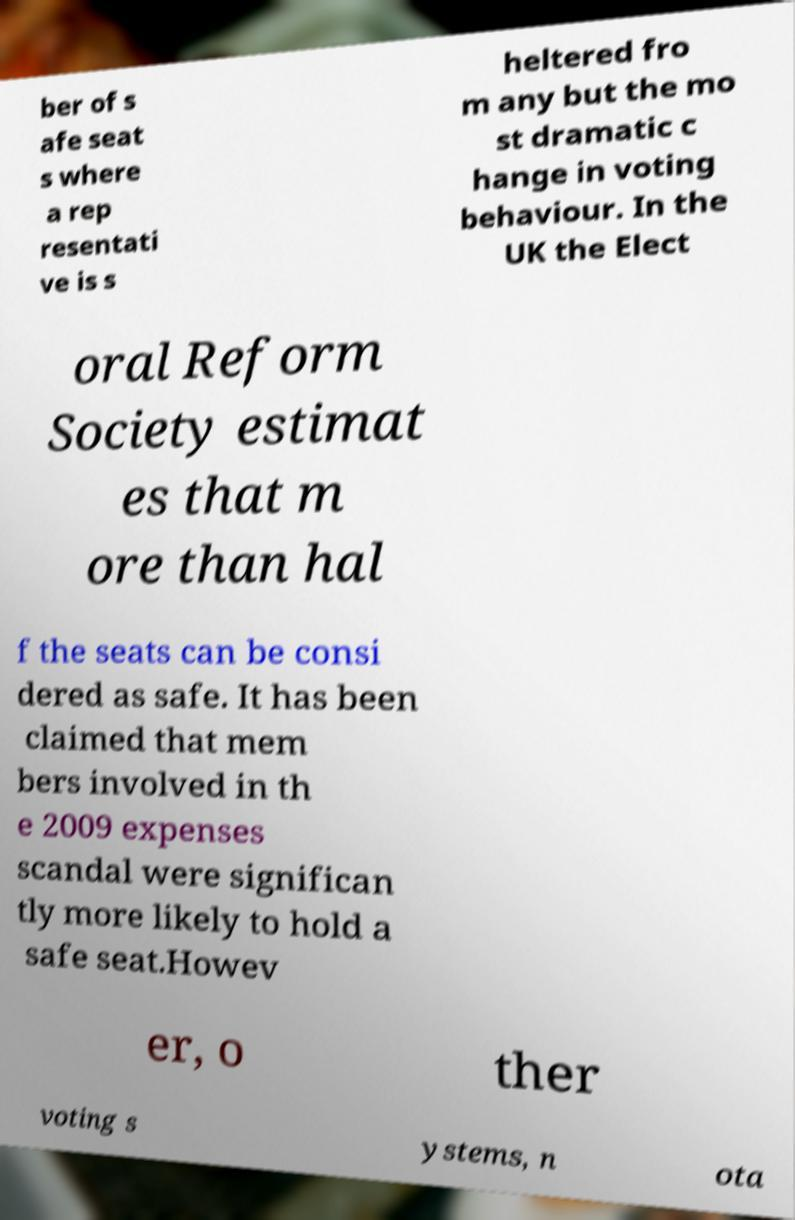Please read and relay the text visible in this image. What does it say? ber of s afe seat s where a rep resentati ve is s heltered fro m any but the mo st dramatic c hange in voting behaviour. In the UK the Elect oral Reform Society estimat es that m ore than hal f the seats can be consi dered as safe. It has been claimed that mem bers involved in th e 2009 expenses scandal were significan tly more likely to hold a safe seat.Howev er, o ther voting s ystems, n ota 